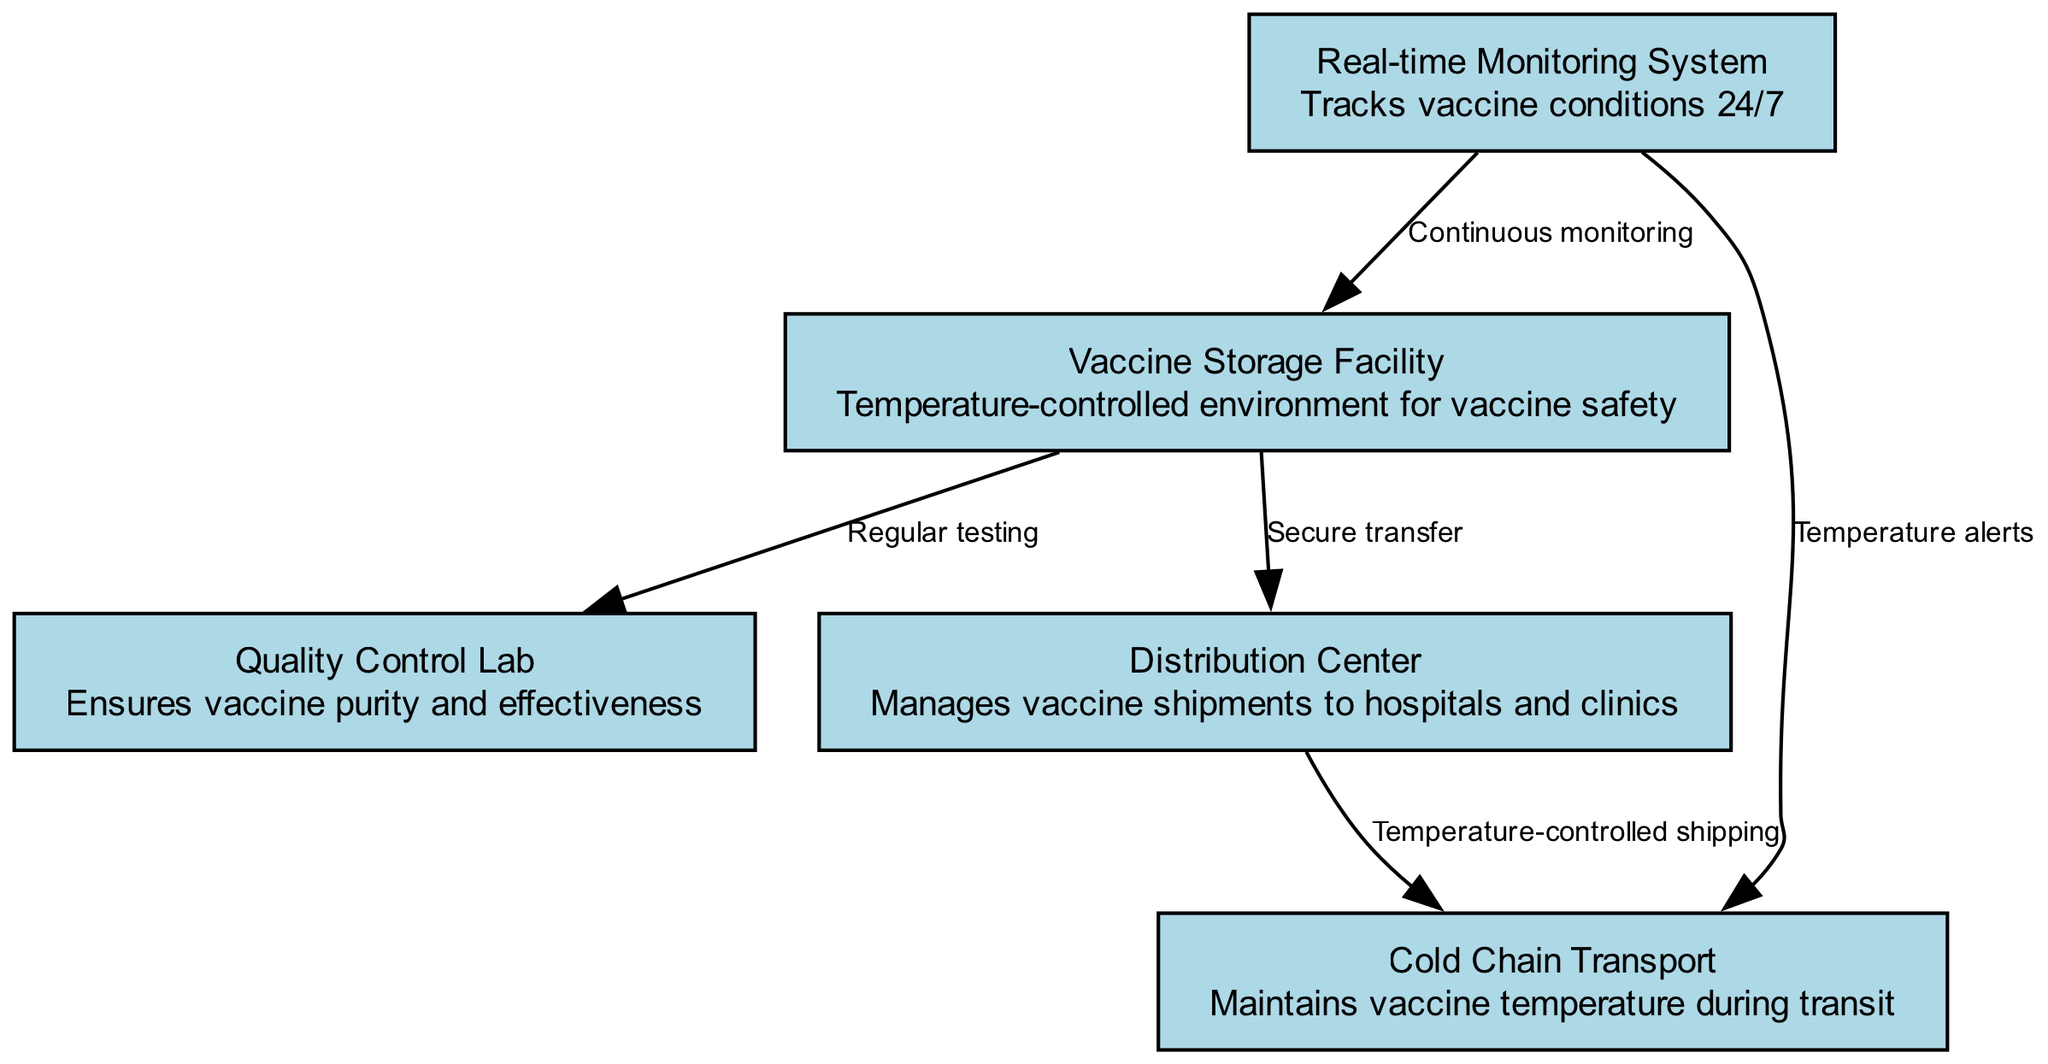What is the label of the storage facility? The diagram includes a node labeled "Vaccine Storage Facility," which serves as the central location for vaccines with a temperature-controlled environment for their safety.
Answer: Vaccine Storage Facility How many nodes are present in the diagram? Counting the nodes listed in the diagram, we see five distinct nodes: Vaccine Storage Facility, Quality Control Lab, Distribution Center, Cold Chain Transport, and Real-time Monitoring System.
Answer: 5 What process is indicated between the vaccine storage and quality control? The edge connecting the Vaccine Storage Facility and Quality Control Lab indicates "Regular testing," which suggests the vaccines are tested consistently for safety and efficacy.
Answer: Regular testing Which facility handles vaccine shipments? The "Distribution Center" is indicated as responsible for managing the vaccine shipments to hospitals and clinics, as shown in the diagram.
Answer: Distribution Center What alerts does the monitoring system provide during transport? The diagram states that the Real-time Monitoring System sends "Temperature alerts" to ensure compliance with the required temperature during the Cold Chain Transport of vaccines.
Answer: Temperature alerts Which parameter is continuously monitored in the storage facility? According to the diagram, the Real-time Monitoring System is depicted as providing "Continuous monitoring" of conditions within the Vaccine Storage Facility, ensuring optimal safety.
Answer: Continuous monitoring How do vaccines leave the storage facility? The connection labeled "Secure transfer" indicates the process by which vaccines are transferred securely from the Vaccine Storage Facility to the Distribution Center for further distribution.
Answer: Secure transfer Which system monitors the cold chain during transport? The Real-time Monitoring System is linked to the Cold Chain Transport, where it provides monitoring, emphasizing oversight of the transportation conditions necessary for vaccine safety.
Answer: Real-time Monitoring System What aspect does the Quality Control Lab ensure? The Quality Control Lab is described as ensuring "vaccine purity and effectiveness," highlighting its critical role in confirming the safety and efficacy of the vaccines stored and distributed.
Answer: Vaccine purity and effectiveness 